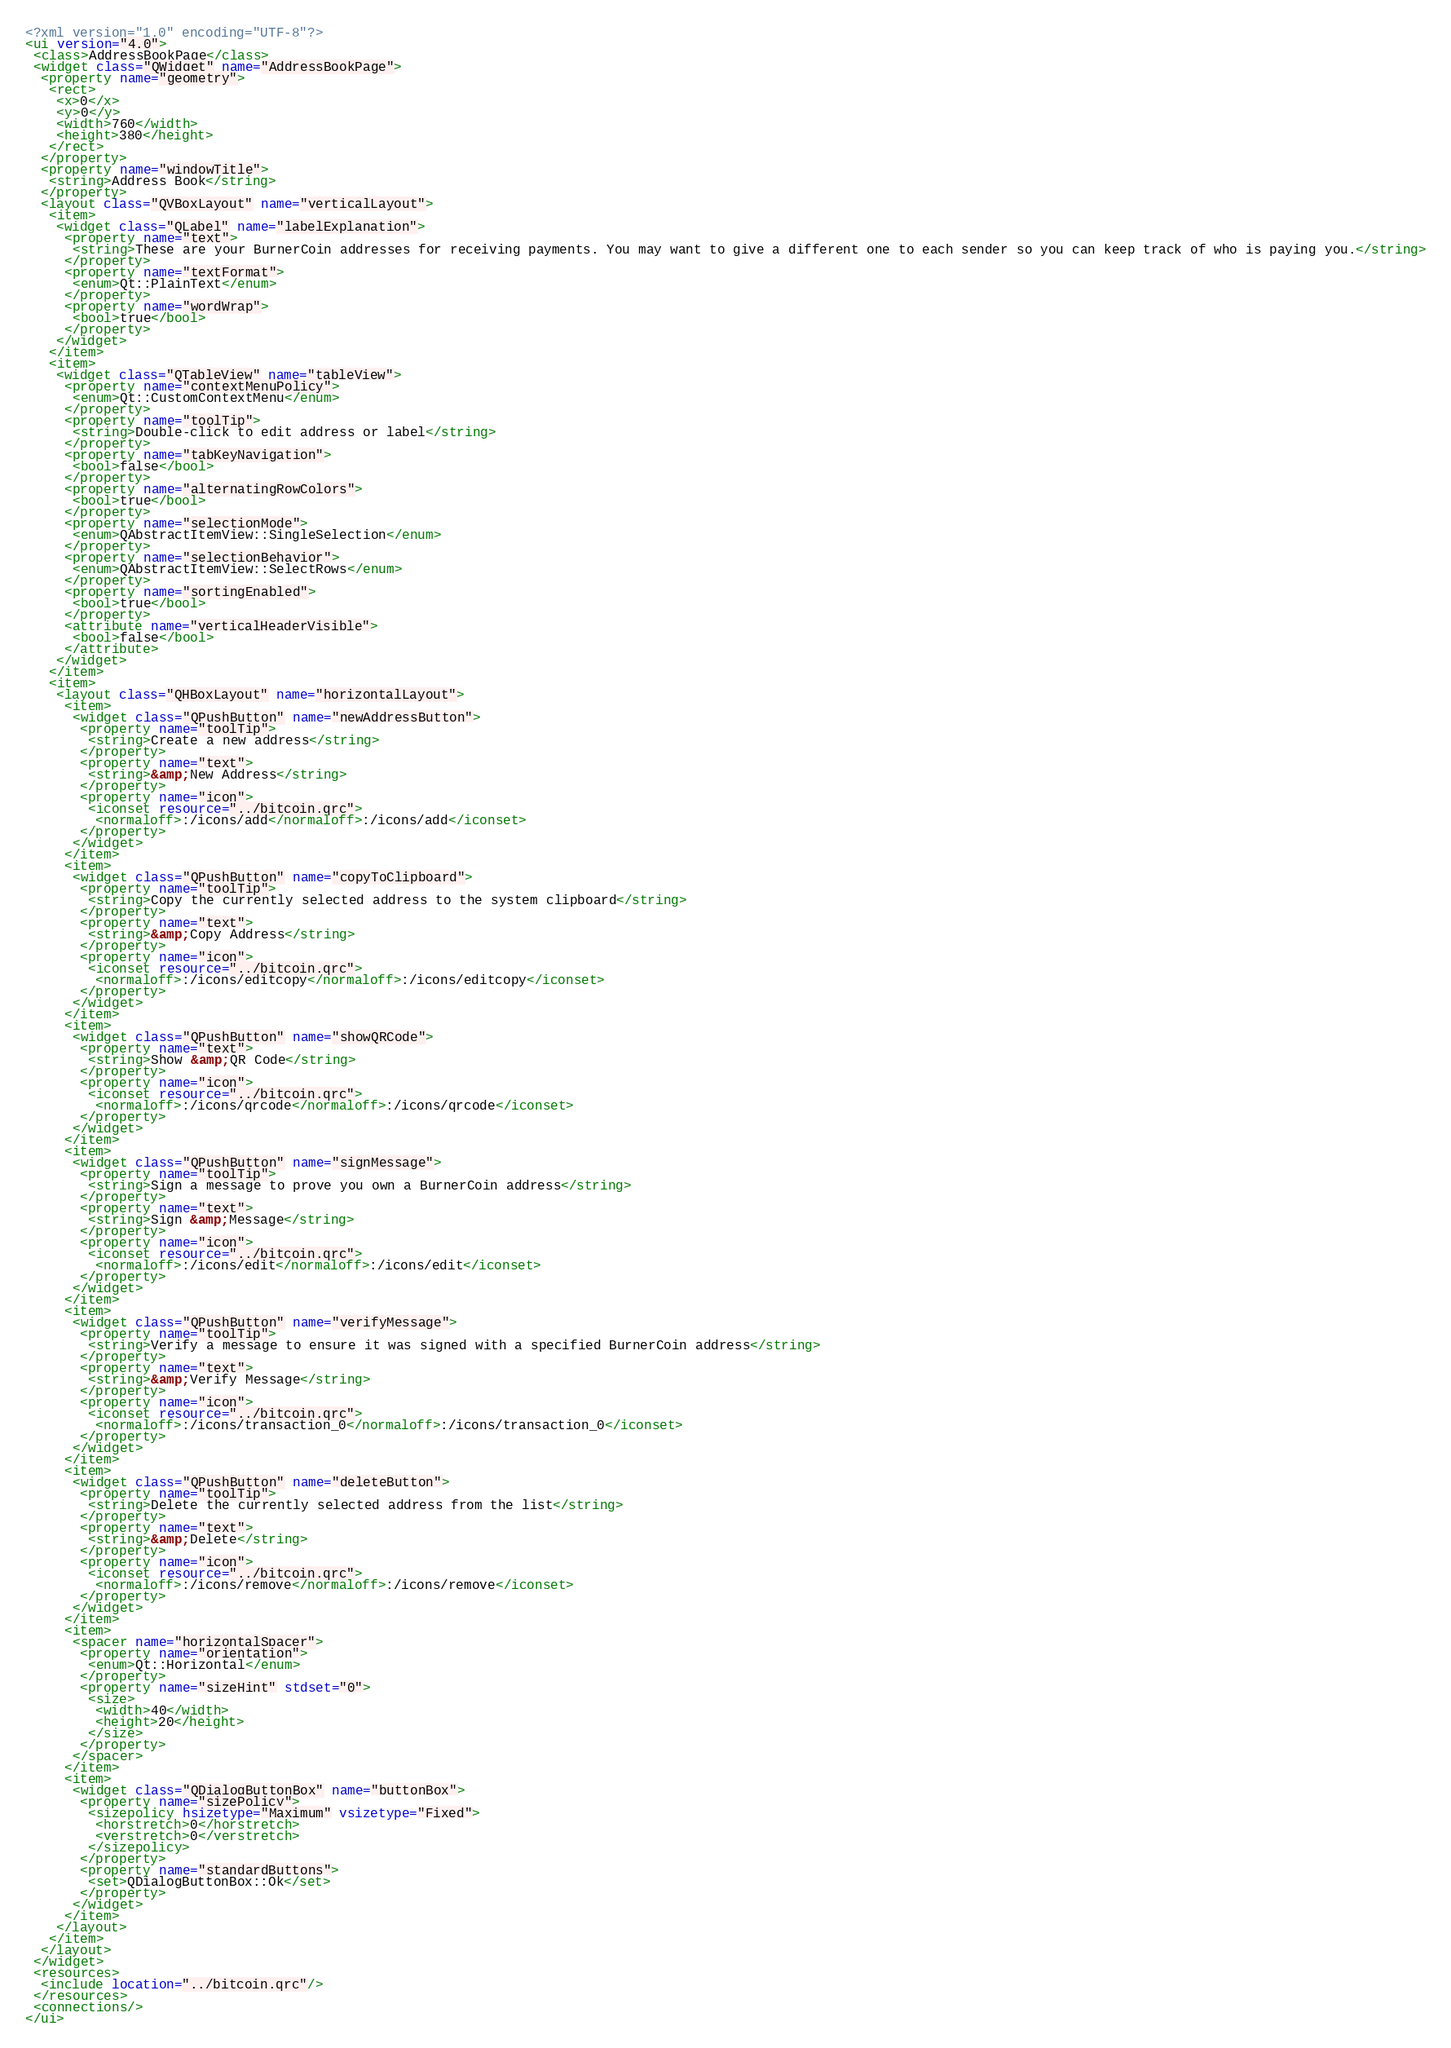Convert code to text. <code><loc_0><loc_0><loc_500><loc_500><_XML_><?xml version="1.0" encoding="UTF-8"?>
<ui version="4.0">
 <class>AddressBookPage</class>
 <widget class="QWidget" name="AddressBookPage">
  <property name="geometry">
   <rect>
    <x>0</x>
    <y>0</y>
    <width>760</width>
    <height>380</height>
   </rect>
  </property>
  <property name="windowTitle">
   <string>Address Book</string>
  </property>
  <layout class="QVBoxLayout" name="verticalLayout">
   <item>
    <widget class="QLabel" name="labelExplanation">
     <property name="text">
      <string>These are your BurnerCoin addresses for receiving payments. You may want to give a different one to each sender so you can keep track of who is paying you.</string>
     </property>
     <property name="textFormat">
      <enum>Qt::PlainText</enum>
     </property>
     <property name="wordWrap">
      <bool>true</bool>
     </property>
    </widget>
   </item>
   <item>
    <widget class="QTableView" name="tableView">
     <property name="contextMenuPolicy">
      <enum>Qt::CustomContextMenu</enum>
     </property>
     <property name="toolTip">
      <string>Double-click to edit address or label</string>
     </property>
     <property name="tabKeyNavigation">
      <bool>false</bool>
     </property>
     <property name="alternatingRowColors">
      <bool>true</bool>
     </property>
     <property name="selectionMode">
      <enum>QAbstractItemView::SingleSelection</enum>
     </property>
     <property name="selectionBehavior">
      <enum>QAbstractItemView::SelectRows</enum>
     </property>
     <property name="sortingEnabled">
      <bool>true</bool>
     </property>
     <attribute name="verticalHeaderVisible">
      <bool>false</bool>
     </attribute>
    </widget>
   </item>
   <item>
    <layout class="QHBoxLayout" name="horizontalLayout">
     <item>
      <widget class="QPushButton" name="newAddressButton">
       <property name="toolTip">
        <string>Create a new address</string>
       </property>
       <property name="text">
        <string>&amp;New Address</string>
       </property>
       <property name="icon">
        <iconset resource="../bitcoin.qrc">
         <normaloff>:/icons/add</normaloff>:/icons/add</iconset>
       </property>
      </widget>
     </item>
     <item>
      <widget class="QPushButton" name="copyToClipboard">
       <property name="toolTip">
        <string>Copy the currently selected address to the system clipboard</string>
       </property>
       <property name="text">
        <string>&amp;Copy Address</string>
       </property>
       <property name="icon">
        <iconset resource="../bitcoin.qrc">
         <normaloff>:/icons/editcopy</normaloff>:/icons/editcopy</iconset>
       </property>
      </widget>
     </item>
     <item>
      <widget class="QPushButton" name="showQRCode">
       <property name="text">
        <string>Show &amp;QR Code</string>
       </property>
       <property name="icon">
        <iconset resource="../bitcoin.qrc">
         <normaloff>:/icons/qrcode</normaloff>:/icons/qrcode</iconset>
       </property>
      </widget>
     </item>
     <item>
      <widget class="QPushButton" name="signMessage">
       <property name="toolTip">
        <string>Sign a message to prove you own a BurnerCoin address</string>
       </property>
       <property name="text">
        <string>Sign &amp;Message</string>
       </property>
       <property name="icon">
        <iconset resource="../bitcoin.qrc">
         <normaloff>:/icons/edit</normaloff>:/icons/edit</iconset>
       </property>
      </widget>
     </item>
     <item>
      <widget class="QPushButton" name="verifyMessage">
       <property name="toolTip">
        <string>Verify a message to ensure it was signed with a specified BurnerCoin address</string>
       </property>
       <property name="text">
        <string>&amp;Verify Message</string>
       </property>
       <property name="icon">
        <iconset resource="../bitcoin.qrc">
         <normaloff>:/icons/transaction_0</normaloff>:/icons/transaction_0</iconset>
       </property>
      </widget>
     </item>
     <item>
      <widget class="QPushButton" name="deleteButton">
       <property name="toolTip">
        <string>Delete the currently selected address from the list</string>
       </property>
       <property name="text">
        <string>&amp;Delete</string>
       </property>
       <property name="icon">
        <iconset resource="../bitcoin.qrc">
         <normaloff>:/icons/remove</normaloff>:/icons/remove</iconset>
       </property>
      </widget>
     </item>
     <item>
      <spacer name="horizontalSpacer">
       <property name="orientation">
        <enum>Qt::Horizontal</enum>
       </property>
       <property name="sizeHint" stdset="0">
        <size>
         <width>40</width>
         <height>20</height>
        </size>
       </property>
      </spacer>
     </item>
     <item>
      <widget class="QDialogButtonBox" name="buttonBox">
       <property name="sizePolicy">
        <sizepolicy hsizetype="Maximum" vsizetype="Fixed">
         <horstretch>0</horstretch>
         <verstretch>0</verstretch>
        </sizepolicy>
       </property>
       <property name="standardButtons">
        <set>QDialogButtonBox::Ok</set>
       </property>
      </widget>
     </item>
    </layout>
   </item>
  </layout>
 </widget>
 <resources>
  <include location="../bitcoin.qrc"/>
 </resources>
 <connections/>
</ui>
</code> 